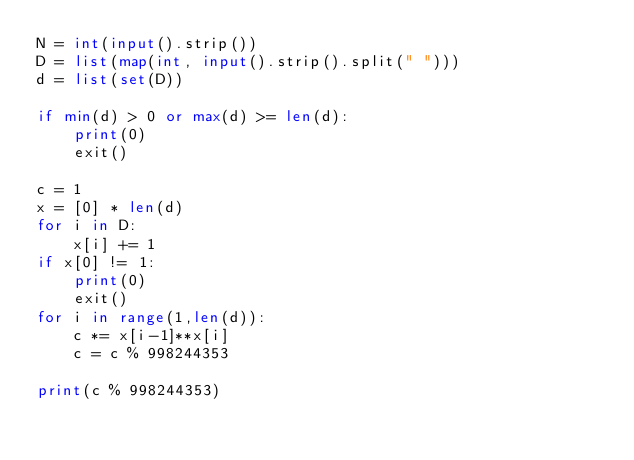<code> <loc_0><loc_0><loc_500><loc_500><_Python_>N = int(input().strip())
D = list(map(int, input().strip().split(" ")))
d = list(set(D))

if min(d) > 0 or max(d) >= len(d):
    print(0)
    exit()

c = 1
x = [0] * len(d)
for i in D:
    x[i] += 1
if x[0] != 1:
    print(0)
    exit()
for i in range(1,len(d)):
    c *= x[i-1]**x[i]
    c = c % 998244353

print(c % 998244353)
</code> 